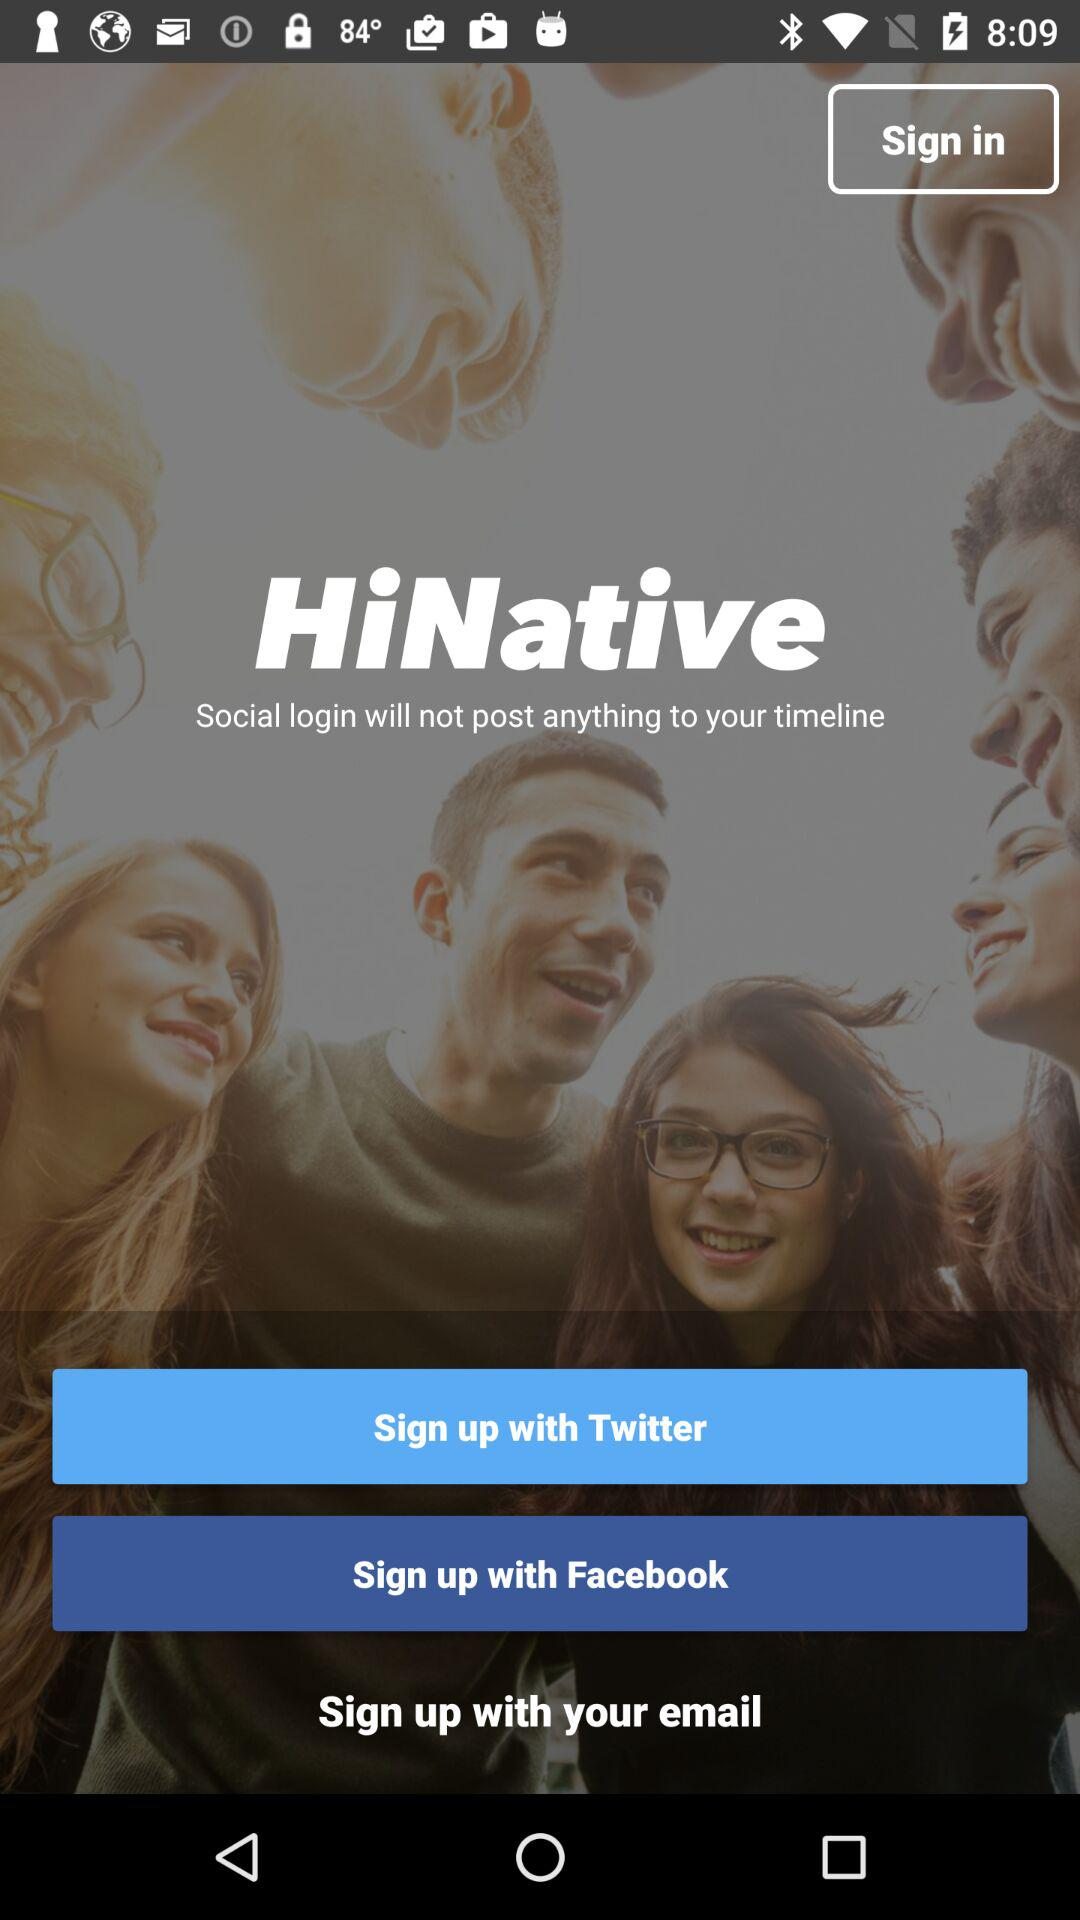How many sign up options are there?
Answer the question using a single word or phrase. 3 